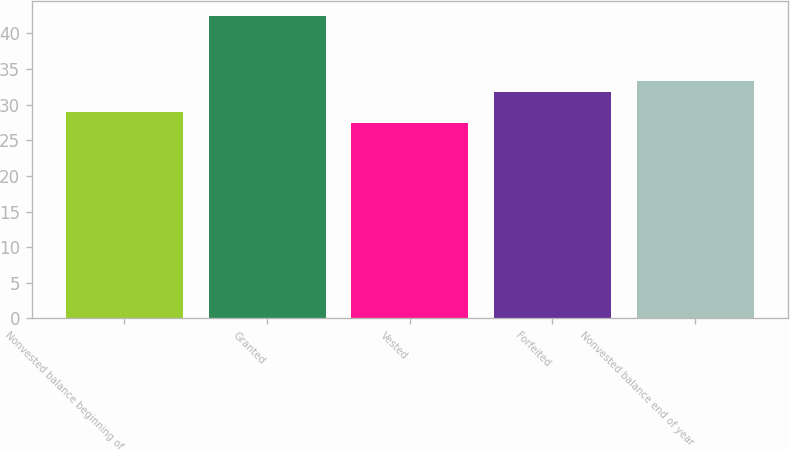<chart> <loc_0><loc_0><loc_500><loc_500><bar_chart><fcel>Nonvested balance beginning of<fcel>Granted<fcel>Vested<fcel>Forfeited<fcel>Nonvested balance end of year<nl><fcel>28.96<fcel>42.36<fcel>27.47<fcel>31.81<fcel>33.3<nl></chart> 